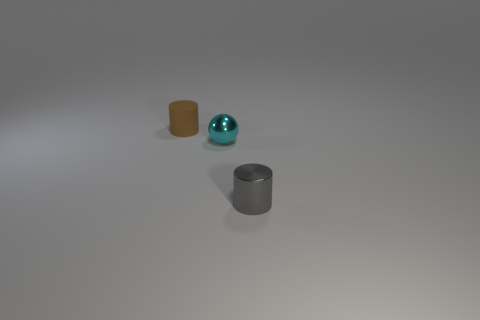Add 2 small matte cylinders. How many objects exist? 5 Subtract all cylinders. How many objects are left? 1 Add 3 cyan rubber things. How many cyan rubber things exist? 3 Subtract 0 red cylinders. How many objects are left? 3 Subtract all cyan objects. Subtract all tiny shiny spheres. How many objects are left? 1 Add 2 matte cylinders. How many matte cylinders are left? 3 